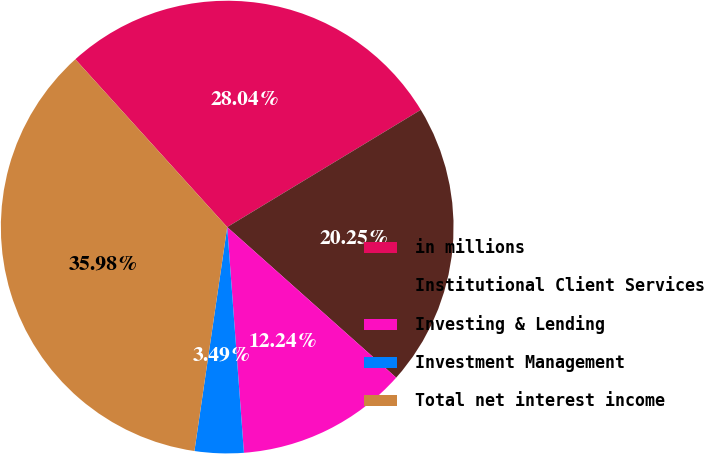Convert chart to OTSL. <chart><loc_0><loc_0><loc_500><loc_500><pie_chart><fcel>in millions<fcel>Institutional Client Services<fcel>Investing & Lending<fcel>Investment Management<fcel>Total net interest income<nl><fcel>28.04%<fcel>20.25%<fcel>12.24%<fcel>3.49%<fcel>35.98%<nl></chart> 